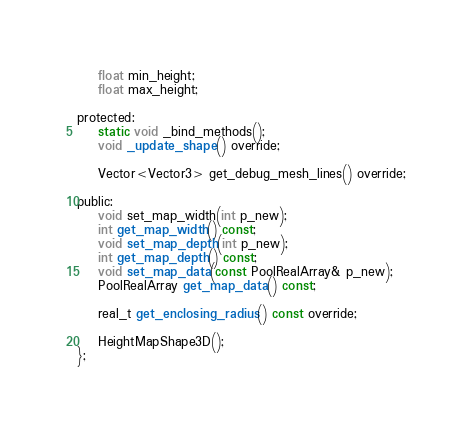Convert code to text. <code><loc_0><loc_0><loc_500><loc_500><_C_>    float min_height;
    float max_height;

protected:
    static void _bind_methods();
    void _update_shape() override;

    Vector<Vector3> get_debug_mesh_lines() override;

public:
    void set_map_width(int p_new);
    int get_map_width() const;
    void set_map_depth(int p_new);
    int get_map_depth() const;
    void set_map_data(const PoolRealArray& p_new);
    PoolRealArray get_map_data() const;

    real_t get_enclosing_radius() const override;

    HeightMapShape3D();
};
</code> 